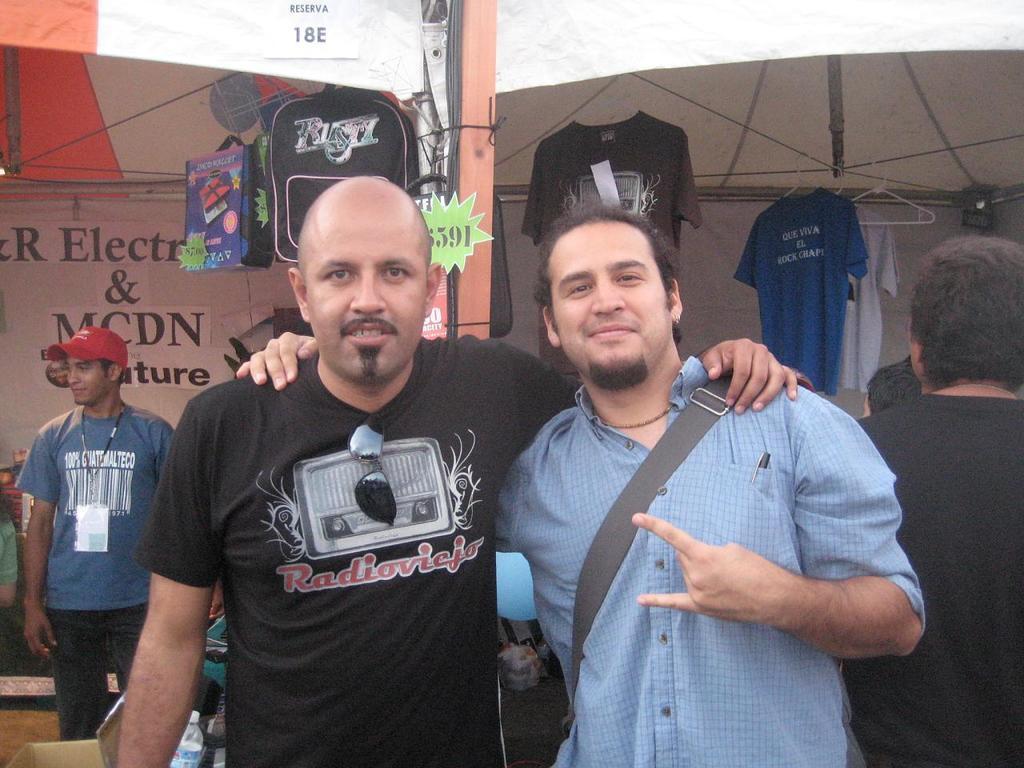Describe this image in one or two sentences. In this picture we can see two men standing in the front,in the background there are some t-shirts and bags hanging over there, on the left side there is a person standing, he wore a cap and a tag, we can see goggles here. 